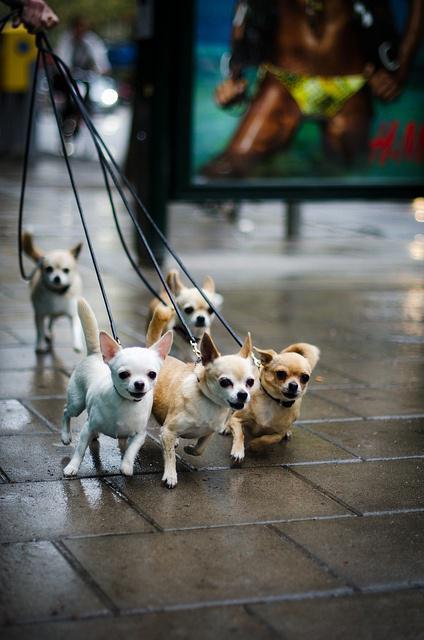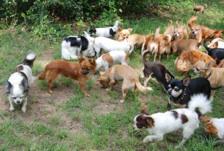The first image is the image on the left, the second image is the image on the right. Assess this claim about the two images: "A cat is in the middle of a horizontal row of dogs in one image.". Correct or not? Answer yes or no. No. The first image is the image on the left, the second image is the image on the right. Evaluate the accuracy of this statement regarding the images: "There are five dogs in the left picture.". Is it true? Answer yes or no. Yes. 